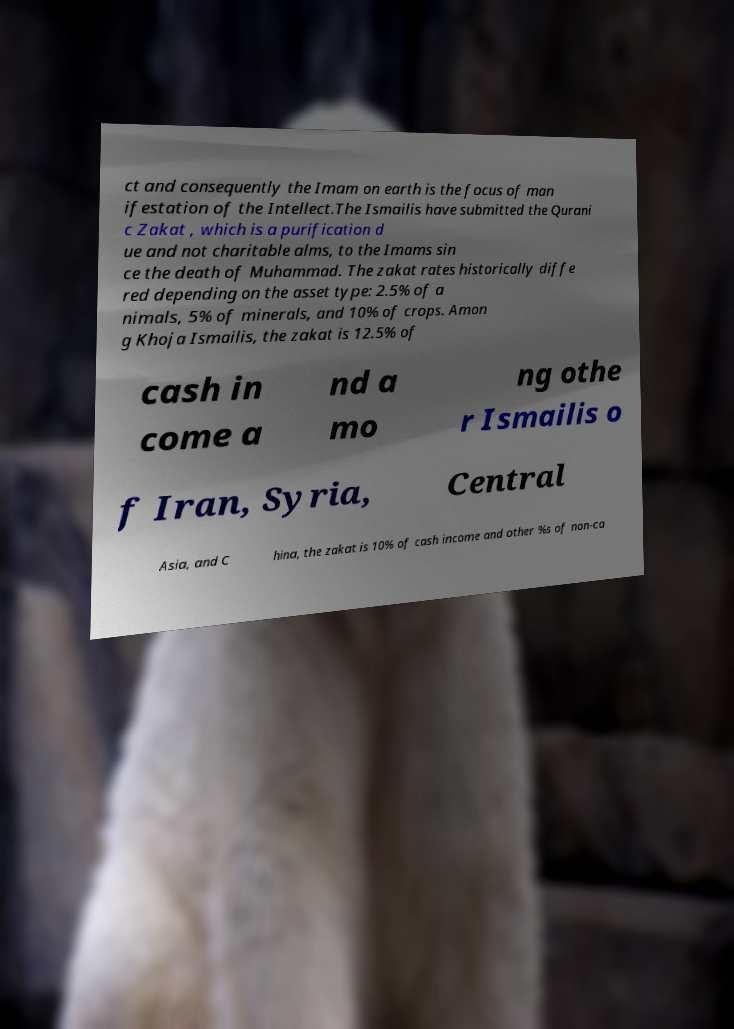Please read and relay the text visible in this image. What does it say? ct and consequently the Imam on earth is the focus of man ifestation of the Intellect.The Ismailis have submitted the Qurani c Zakat , which is a purification d ue and not charitable alms, to the Imams sin ce the death of Muhammad. The zakat rates historically diffe red depending on the asset type: 2.5% of a nimals, 5% of minerals, and 10% of crops. Amon g Khoja Ismailis, the zakat is 12.5% of cash in come a nd a mo ng othe r Ismailis o f Iran, Syria, Central Asia, and C hina, the zakat is 10% of cash income and other %s of non-ca 